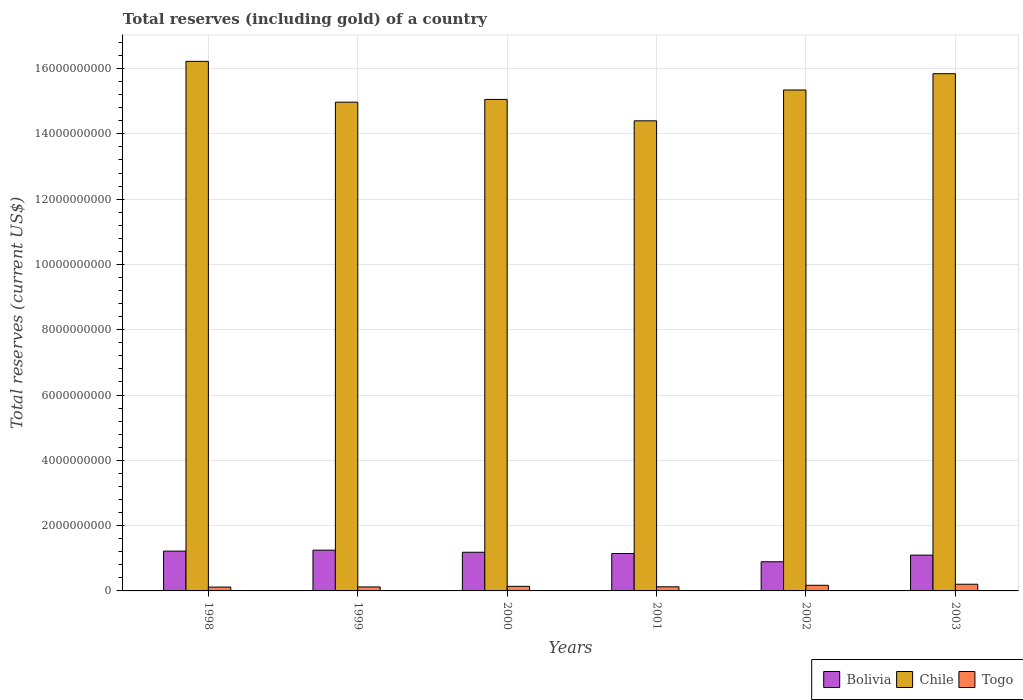How many different coloured bars are there?
Your answer should be very brief. 3. How many groups of bars are there?
Keep it short and to the point. 6. Are the number of bars per tick equal to the number of legend labels?
Provide a succinct answer. Yes. What is the label of the 4th group of bars from the left?
Provide a succinct answer. 2001. What is the total reserves (including gold) in Togo in 2003?
Keep it short and to the point. 2.05e+08. Across all years, what is the maximum total reserves (including gold) in Togo?
Give a very brief answer. 2.05e+08. Across all years, what is the minimum total reserves (including gold) in Bolivia?
Provide a short and direct response. 8.93e+08. In which year was the total reserves (including gold) in Bolivia maximum?
Offer a terse response. 1999. What is the total total reserves (including gold) in Bolivia in the graph?
Provide a succinct answer. 6.79e+09. What is the difference between the total reserves (including gold) in Togo in 1999 and that in 2003?
Offer a very short reply. -8.28e+07. What is the difference between the total reserves (including gold) in Togo in 2000 and the total reserves (including gold) in Chile in 2001?
Ensure brevity in your answer.  -1.43e+1. What is the average total reserves (including gold) in Chile per year?
Offer a terse response. 1.53e+1. In the year 2003, what is the difference between the total reserves (including gold) in Togo and total reserves (including gold) in Chile?
Provide a succinct answer. -1.56e+1. What is the ratio of the total reserves (including gold) in Chile in 1999 to that in 2000?
Keep it short and to the point. 0.99. What is the difference between the highest and the second highest total reserves (including gold) in Bolivia?
Keep it short and to the point. 2.97e+07. What is the difference between the highest and the lowest total reserves (including gold) in Bolivia?
Offer a terse response. 3.56e+08. In how many years, is the total reserves (including gold) in Chile greater than the average total reserves (including gold) in Chile taken over all years?
Your response must be concise. 3. Is the sum of the total reserves (including gold) in Bolivia in 1998 and 2000 greater than the maximum total reserves (including gold) in Togo across all years?
Give a very brief answer. Yes. What does the 3rd bar from the left in 2001 represents?
Your answer should be compact. Togo. What does the 1st bar from the right in 2000 represents?
Your answer should be compact. Togo. How many bars are there?
Give a very brief answer. 18. Does the graph contain any zero values?
Offer a very short reply. No. Does the graph contain grids?
Provide a short and direct response. Yes. Where does the legend appear in the graph?
Offer a very short reply. Bottom right. How many legend labels are there?
Offer a very short reply. 3. How are the legend labels stacked?
Your response must be concise. Horizontal. What is the title of the graph?
Provide a short and direct response. Total reserves (including gold) of a country. Does "Upper middle income" appear as one of the legend labels in the graph?
Offer a terse response. No. What is the label or title of the Y-axis?
Give a very brief answer. Total reserves (current US$). What is the Total reserves (current US$) of Bolivia in 1998?
Your answer should be compact. 1.22e+09. What is the Total reserves (current US$) of Chile in 1998?
Provide a succinct answer. 1.62e+1. What is the Total reserves (current US$) in Togo in 1998?
Give a very brief answer. 1.18e+08. What is the Total reserves (current US$) in Bolivia in 1999?
Your answer should be very brief. 1.25e+09. What is the Total reserves (current US$) of Chile in 1999?
Make the answer very short. 1.50e+1. What is the Total reserves (current US$) in Togo in 1999?
Make the answer very short. 1.22e+08. What is the Total reserves (current US$) of Bolivia in 2000?
Offer a very short reply. 1.18e+09. What is the Total reserves (current US$) of Chile in 2000?
Make the answer very short. 1.51e+1. What is the Total reserves (current US$) of Togo in 2000?
Give a very brief answer. 1.41e+08. What is the Total reserves (current US$) in Bolivia in 2001?
Provide a succinct answer. 1.15e+09. What is the Total reserves (current US$) in Chile in 2001?
Provide a succinct answer. 1.44e+1. What is the Total reserves (current US$) in Togo in 2001?
Your answer should be very brief. 1.26e+08. What is the Total reserves (current US$) in Bolivia in 2002?
Offer a very short reply. 8.93e+08. What is the Total reserves (current US$) in Chile in 2002?
Your answer should be compact. 1.53e+1. What is the Total reserves (current US$) of Togo in 2002?
Ensure brevity in your answer.  1.72e+08. What is the Total reserves (current US$) of Bolivia in 2003?
Offer a terse response. 1.10e+09. What is the Total reserves (current US$) in Chile in 2003?
Offer a terse response. 1.58e+1. What is the Total reserves (current US$) of Togo in 2003?
Offer a very short reply. 2.05e+08. Across all years, what is the maximum Total reserves (current US$) in Bolivia?
Your response must be concise. 1.25e+09. Across all years, what is the maximum Total reserves (current US$) in Chile?
Keep it short and to the point. 1.62e+1. Across all years, what is the maximum Total reserves (current US$) in Togo?
Offer a terse response. 2.05e+08. Across all years, what is the minimum Total reserves (current US$) in Bolivia?
Provide a short and direct response. 8.93e+08. Across all years, what is the minimum Total reserves (current US$) of Chile?
Keep it short and to the point. 1.44e+1. Across all years, what is the minimum Total reserves (current US$) of Togo?
Provide a short and direct response. 1.18e+08. What is the total Total reserves (current US$) in Bolivia in the graph?
Offer a very short reply. 6.79e+09. What is the total Total reserves (current US$) in Chile in the graph?
Your answer should be compact. 9.18e+1. What is the total Total reserves (current US$) in Togo in the graph?
Your answer should be compact. 8.84e+08. What is the difference between the Total reserves (current US$) of Bolivia in 1998 and that in 1999?
Keep it short and to the point. -2.97e+07. What is the difference between the Total reserves (current US$) in Chile in 1998 and that in 1999?
Provide a short and direct response. 1.25e+09. What is the difference between the Total reserves (current US$) of Togo in 1998 and that in 1999?
Give a very brief answer. -4.31e+06. What is the difference between the Total reserves (current US$) in Bolivia in 1998 and that in 2000?
Offer a terse response. 3.48e+07. What is the difference between the Total reserves (current US$) of Chile in 1998 and that in 2000?
Offer a terse response. 1.17e+09. What is the difference between the Total reserves (current US$) of Togo in 1998 and that in 2000?
Provide a short and direct response. -2.31e+07. What is the difference between the Total reserves (current US$) of Bolivia in 1998 and that in 2001?
Offer a terse response. 7.28e+07. What is the difference between the Total reserves (current US$) in Chile in 1998 and that in 2001?
Ensure brevity in your answer.  1.82e+09. What is the difference between the Total reserves (current US$) of Togo in 1998 and that in 2001?
Your answer should be very brief. -8.42e+06. What is the difference between the Total reserves (current US$) of Bolivia in 1998 and that in 2002?
Your answer should be very brief. 3.26e+08. What is the difference between the Total reserves (current US$) of Chile in 1998 and that in 2002?
Keep it short and to the point. 8.77e+08. What is the difference between the Total reserves (current US$) in Togo in 1998 and that in 2002?
Provide a short and direct response. -5.47e+07. What is the difference between the Total reserves (current US$) of Bolivia in 1998 and that in 2003?
Make the answer very short. 1.22e+08. What is the difference between the Total reserves (current US$) of Chile in 1998 and that in 2003?
Keep it short and to the point. 3.78e+08. What is the difference between the Total reserves (current US$) of Togo in 1998 and that in 2003?
Give a very brief answer. -8.71e+07. What is the difference between the Total reserves (current US$) of Bolivia in 1999 and that in 2000?
Make the answer very short. 6.45e+07. What is the difference between the Total reserves (current US$) of Chile in 1999 and that in 2000?
Offer a very short reply. -8.45e+07. What is the difference between the Total reserves (current US$) in Togo in 1999 and that in 2000?
Your answer should be compact. -1.88e+07. What is the difference between the Total reserves (current US$) in Bolivia in 1999 and that in 2001?
Ensure brevity in your answer.  1.03e+08. What is the difference between the Total reserves (current US$) in Chile in 1999 and that in 2001?
Ensure brevity in your answer.  5.71e+08. What is the difference between the Total reserves (current US$) of Togo in 1999 and that in 2001?
Offer a very short reply. -4.11e+06. What is the difference between the Total reserves (current US$) in Bolivia in 1999 and that in 2002?
Give a very brief answer. 3.56e+08. What is the difference between the Total reserves (current US$) of Chile in 1999 and that in 2002?
Your answer should be compact. -3.73e+08. What is the difference between the Total reserves (current US$) in Togo in 1999 and that in 2002?
Provide a short and direct response. -5.04e+07. What is the difference between the Total reserves (current US$) in Bolivia in 1999 and that in 2003?
Give a very brief answer. 1.52e+08. What is the difference between the Total reserves (current US$) in Chile in 1999 and that in 2003?
Offer a terse response. -8.72e+08. What is the difference between the Total reserves (current US$) in Togo in 1999 and that in 2003?
Ensure brevity in your answer.  -8.28e+07. What is the difference between the Total reserves (current US$) of Bolivia in 2000 and that in 2001?
Ensure brevity in your answer.  3.81e+07. What is the difference between the Total reserves (current US$) in Chile in 2000 and that in 2001?
Keep it short and to the point. 6.56e+08. What is the difference between the Total reserves (current US$) of Togo in 2000 and that in 2001?
Offer a very short reply. 1.47e+07. What is the difference between the Total reserves (current US$) in Bolivia in 2000 and that in 2002?
Keep it short and to the point. 2.91e+08. What is the difference between the Total reserves (current US$) in Chile in 2000 and that in 2002?
Ensure brevity in your answer.  -2.89e+08. What is the difference between the Total reserves (current US$) in Togo in 2000 and that in 2002?
Offer a very short reply. -3.16e+07. What is the difference between the Total reserves (current US$) of Bolivia in 2000 and that in 2003?
Your answer should be very brief. 8.72e+07. What is the difference between the Total reserves (current US$) of Chile in 2000 and that in 2003?
Your response must be concise. -7.88e+08. What is the difference between the Total reserves (current US$) in Togo in 2000 and that in 2003?
Your response must be concise. -6.40e+07. What is the difference between the Total reserves (current US$) of Bolivia in 2001 and that in 2002?
Provide a short and direct response. 2.53e+08. What is the difference between the Total reserves (current US$) of Chile in 2001 and that in 2002?
Provide a succinct answer. -9.44e+08. What is the difference between the Total reserves (current US$) of Togo in 2001 and that in 2002?
Offer a terse response. -4.63e+07. What is the difference between the Total reserves (current US$) in Bolivia in 2001 and that in 2003?
Your response must be concise. 4.91e+07. What is the difference between the Total reserves (current US$) of Chile in 2001 and that in 2003?
Your answer should be compact. -1.44e+09. What is the difference between the Total reserves (current US$) in Togo in 2001 and that in 2003?
Your answer should be very brief. -7.87e+07. What is the difference between the Total reserves (current US$) in Bolivia in 2002 and that in 2003?
Provide a succinct answer. -2.04e+08. What is the difference between the Total reserves (current US$) in Chile in 2002 and that in 2003?
Make the answer very short. -4.99e+08. What is the difference between the Total reserves (current US$) of Togo in 2002 and that in 2003?
Keep it short and to the point. -3.25e+07. What is the difference between the Total reserves (current US$) of Bolivia in 1998 and the Total reserves (current US$) of Chile in 1999?
Your answer should be compact. -1.38e+1. What is the difference between the Total reserves (current US$) of Bolivia in 1998 and the Total reserves (current US$) of Togo in 1999?
Keep it short and to the point. 1.10e+09. What is the difference between the Total reserves (current US$) of Chile in 1998 and the Total reserves (current US$) of Togo in 1999?
Offer a terse response. 1.61e+1. What is the difference between the Total reserves (current US$) in Bolivia in 1998 and the Total reserves (current US$) in Chile in 2000?
Your answer should be very brief. -1.38e+1. What is the difference between the Total reserves (current US$) of Bolivia in 1998 and the Total reserves (current US$) of Togo in 2000?
Your response must be concise. 1.08e+09. What is the difference between the Total reserves (current US$) of Chile in 1998 and the Total reserves (current US$) of Togo in 2000?
Offer a very short reply. 1.61e+1. What is the difference between the Total reserves (current US$) in Bolivia in 1998 and the Total reserves (current US$) in Chile in 2001?
Make the answer very short. -1.32e+1. What is the difference between the Total reserves (current US$) of Bolivia in 1998 and the Total reserves (current US$) of Togo in 2001?
Make the answer very short. 1.09e+09. What is the difference between the Total reserves (current US$) in Chile in 1998 and the Total reserves (current US$) in Togo in 2001?
Ensure brevity in your answer.  1.61e+1. What is the difference between the Total reserves (current US$) of Bolivia in 1998 and the Total reserves (current US$) of Chile in 2002?
Give a very brief answer. -1.41e+1. What is the difference between the Total reserves (current US$) of Bolivia in 1998 and the Total reserves (current US$) of Togo in 2002?
Ensure brevity in your answer.  1.05e+09. What is the difference between the Total reserves (current US$) in Chile in 1998 and the Total reserves (current US$) in Togo in 2002?
Provide a short and direct response. 1.60e+1. What is the difference between the Total reserves (current US$) of Bolivia in 1998 and the Total reserves (current US$) of Chile in 2003?
Your response must be concise. -1.46e+1. What is the difference between the Total reserves (current US$) in Bolivia in 1998 and the Total reserves (current US$) in Togo in 2003?
Offer a very short reply. 1.01e+09. What is the difference between the Total reserves (current US$) in Chile in 1998 and the Total reserves (current US$) in Togo in 2003?
Offer a terse response. 1.60e+1. What is the difference between the Total reserves (current US$) in Bolivia in 1999 and the Total reserves (current US$) in Chile in 2000?
Give a very brief answer. -1.38e+1. What is the difference between the Total reserves (current US$) in Bolivia in 1999 and the Total reserves (current US$) in Togo in 2000?
Offer a terse response. 1.11e+09. What is the difference between the Total reserves (current US$) in Chile in 1999 and the Total reserves (current US$) in Togo in 2000?
Provide a succinct answer. 1.48e+1. What is the difference between the Total reserves (current US$) in Bolivia in 1999 and the Total reserves (current US$) in Chile in 2001?
Your answer should be compact. -1.32e+1. What is the difference between the Total reserves (current US$) of Bolivia in 1999 and the Total reserves (current US$) of Togo in 2001?
Offer a very short reply. 1.12e+09. What is the difference between the Total reserves (current US$) in Chile in 1999 and the Total reserves (current US$) in Togo in 2001?
Keep it short and to the point. 1.48e+1. What is the difference between the Total reserves (current US$) in Bolivia in 1999 and the Total reserves (current US$) in Chile in 2002?
Your answer should be compact. -1.41e+1. What is the difference between the Total reserves (current US$) in Bolivia in 1999 and the Total reserves (current US$) in Togo in 2002?
Offer a terse response. 1.08e+09. What is the difference between the Total reserves (current US$) of Chile in 1999 and the Total reserves (current US$) of Togo in 2002?
Keep it short and to the point. 1.48e+1. What is the difference between the Total reserves (current US$) of Bolivia in 1999 and the Total reserves (current US$) of Chile in 2003?
Your answer should be very brief. -1.46e+1. What is the difference between the Total reserves (current US$) of Bolivia in 1999 and the Total reserves (current US$) of Togo in 2003?
Provide a succinct answer. 1.04e+09. What is the difference between the Total reserves (current US$) of Chile in 1999 and the Total reserves (current US$) of Togo in 2003?
Your answer should be compact. 1.48e+1. What is the difference between the Total reserves (current US$) of Bolivia in 2000 and the Total reserves (current US$) of Chile in 2001?
Ensure brevity in your answer.  -1.32e+1. What is the difference between the Total reserves (current US$) of Bolivia in 2000 and the Total reserves (current US$) of Togo in 2001?
Provide a succinct answer. 1.06e+09. What is the difference between the Total reserves (current US$) in Chile in 2000 and the Total reserves (current US$) in Togo in 2001?
Offer a very short reply. 1.49e+1. What is the difference between the Total reserves (current US$) of Bolivia in 2000 and the Total reserves (current US$) of Chile in 2002?
Ensure brevity in your answer.  -1.42e+1. What is the difference between the Total reserves (current US$) in Bolivia in 2000 and the Total reserves (current US$) in Togo in 2002?
Ensure brevity in your answer.  1.01e+09. What is the difference between the Total reserves (current US$) in Chile in 2000 and the Total reserves (current US$) in Togo in 2002?
Keep it short and to the point. 1.49e+1. What is the difference between the Total reserves (current US$) of Bolivia in 2000 and the Total reserves (current US$) of Chile in 2003?
Provide a short and direct response. -1.47e+1. What is the difference between the Total reserves (current US$) in Bolivia in 2000 and the Total reserves (current US$) in Togo in 2003?
Provide a succinct answer. 9.79e+08. What is the difference between the Total reserves (current US$) of Chile in 2000 and the Total reserves (current US$) of Togo in 2003?
Your response must be concise. 1.49e+1. What is the difference between the Total reserves (current US$) of Bolivia in 2001 and the Total reserves (current US$) of Chile in 2002?
Offer a terse response. -1.42e+1. What is the difference between the Total reserves (current US$) in Bolivia in 2001 and the Total reserves (current US$) in Togo in 2002?
Your answer should be compact. 9.74e+08. What is the difference between the Total reserves (current US$) in Chile in 2001 and the Total reserves (current US$) in Togo in 2002?
Your answer should be compact. 1.42e+1. What is the difference between the Total reserves (current US$) in Bolivia in 2001 and the Total reserves (current US$) in Chile in 2003?
Your answer should be compact. -1.47e+1. What is the difference between the Total reserves (current US$) in Bolivia in 2001 and the Total reserves (current US$) in Togo in 2003?
Your response must be concise. 9.41e+08. What is the difference between the Total reserves (current US$) in Chile in 2001 and the Total reserves (current US$) in Togo in 2003?
Give a very brief answer. 1.42e+1. What is the difference between the Total reserves (current US$) in Bolivia in 2002 and the Total reserves (current US$) in Chile in 2003?
Your answer should be compact. -1.50e+1. What is the difference between the Total reserves (current US$) of Bolivia in 2002 and the Total reserves (current US$) of Togo in 2003?
Provide a succinct answer. 6.88e+08. What is the difference between the Total reserves (current US$) in Chile in 2002 and the Total reserves (current US$) in Togo in 2003?
Your answer should be compact. 1.51e+1. What is the average Total reserves (current US$) of Bolivia per year?
Provide a succinct answer. 1.13e+09. What is the average Total reserves (current US$) in Chile per year?
Provide a succinct answer. 1.53e+1. What is the average Total reserves (current US$) in Togo per year?
Your answer should be compact. 1.47e+08. In the year 1998, what is the difference between the Total reserves (current US$) in Bolivia and Total reserves (current US$) in Chile?
Your response must be concise. -1.50e+1. In the year 1998, what is the difference between the Total reserves (current US$) in Bolivia and Total reserves (current US$) in Togo?
Provide a succinct answer. 1.10e+09. In the year 1998, what is the difference between the Total reserves (current US$) of Chile and Total reserves (current US$) of Togo?
Ensure brevity in your answer.  1.61e+1. In the year 1999, what is the difference between the Total reserves (current US$) of Bolivia and Total reserves (current US$) of Chile?
Your answer should be compact. -1.37e+1. In the year 1999, what is the difference between the Total reserves (current US$) of Bolivia and Total reserves (current US$) of Togo?
Provide a short and direct response. 1.13e+09. In the year 1999, what is the difference between the Total reserves (current US$) of Chile and Total reserves (current US$) of Togo?
Give a very brief answer. 1.48e+1. In the year 2000, what is the difference between the Total reserves (current US$) of Bolivia and Total reserves (current US$) of Chile?
Your answer should be compact. -1.39e+1. In the year 2000, what is the difference between the Total reserves (current US$) in Bolivia and Total reserves (current US$) in Togo?
Offer a terse response. 1.04e+09. In the year 2000, what is the difference between the Total reserves (current US$) in Chile and Total reserves (current US$) in Togo?
Your answer should be compact. 1.49e+1. In the year 2001, what is the difference between the Total reserves (current US$) in Bolivia and Total reserves (current US$) in Chile?
Give a very brief answer. -1.33e+1. In the year 2001, what is the difference between the Total reserves (current US$) of Bolivia and Total reserves (current US$) of Togo?
Provide a short and direct response. 1.02e+09. In the year 2001, what is the difference between the Total reserves (current US$) in Chile and Total reserves (current US$) in Togo?
Offer a very short reply. 1.43e+1. In the year 2002, what is the difference between the Total reserves (current US$) in Bolivia and Total reserves (current US$) in Chile?
Your answer should be very brief. -1.45e+1. In the year 2002, what is the difference between the Total reserves (current US$) of Bolivia and Total reserves (current US$) of Togo?
Your response must be concise. 7.20e+08. In the year 2002, what is the difference between the Total reserves (current US$) of Chile and Total reserves (current US$) of Togo?
Your response must be concise. 1.52e+1. In the year 2003, what is the difference between the Total reserves (current US$) in Bolivia and Total reserves (current US$) in Chile?
Provide a short and direct response. -1.47e+1. In the year 2003, what is the difference between the Total reserves (current US$) of Bolivia and Total reserves (current US$) of Togo?
Your answer should be very brief. 8.92e+08. In the year 2003, what is the difference between the Total reserves (current US$) in Chile and Total reserves (current US$) in Togo?
Offer a terse response. 1.56e+1. What is the ratio of the Total reserves (current US$) of Bolivia in 1998 to that in 1999?
Ensure brevity in your answer.  0.98. What is the ratio of the Total reserves (current US$) in Chile in 1998 to that in 1999?
Ensure brevity in your answer.  1.08. What is the ratio of the Total reserves (current US$) in Togo in 1998 to that in 1999?
Your response must be concise. 0.96. What is the ratio of the Total reserves (current US$) of Bolivia in 1998 to that in 2000?
Your answer should be very brief. 1.03. What is the ratio of the Total reserves (current US$) in Chile in 1998 to that in 2000?
Your answer should be very brief. 1.08. What is the ratio of the Total reserves (current US$) in Togo in 1998 to that in 2000?
Ensure brevity in your answer.  0.84. What is the ratio of the Total reserves (current US$) in Bolivia in 1998 to that in 2001?
Offer a terse response. 1.06. What is the ratio of the Total reserves (current US$) of Chile in 1998 to that in 2001?
Provide a short and direct response. 1.13. What is the ratio of the Total reserves (current US$) in Bolivia in 1998 to that in 2002?
Provide a short and direct response. 1.37. What is the ratio of the Total reserves (current US$) of Chile in 1998 to that in 2002?
Your response must be concise. 1.06. What is the ratio of the Total reserves (current US$) in Togo in 1998 to that in 2002?
Your response must be concise. 0.68. What is the ratio of the Total reserves (current US$) in Bolivia in 1998 to that in 2003?
Ensure brevity in your answer.  1.11. What is the ratio of the Total reserves (current US$) of Chile in 1998 to that in 2003?
Provide a succinct answer. 1.02. What is the ratio of the Total reserves (current US$) in Togo in 1998 to that in 2003?
Your answer should be compact. 0.57. What is the ratio of the Total reserves (current US$) of Bolivia in 1999 to that in 2000?
Your answer should be compact. 1.05. What is the ratio of the Total reserves (current US$) in Togo in 1999 to that in 2000?
Offer a terse response. 0.87. What is the ratio of the Total reserves (current US$) in Bolivia in 1999 to that in 2001?
Your answer should be compact. 1.09. What is the ratio of the Total reserves (current US$) of Chile in 1999 to that in 2001?
Give a very brief answer. 1.04. What is the ratio of the Total reserves (current US$) in Togo in 1999 to that in 2001?
Give a very brief answer. 0.97. What is the ratio of the Total reserves (current US$) in Bolivia in 1999 to that in 2002?
Offer a terse response. 1.4. What is the ratio of the Total reserves (current US$) in Chile in 1999 to that in 2002?
Offer a very short reply. 0.98. What is the ratio of the Total reserves (current US$) in Togo in 1999 to that in 2002?
Your response must be concise. 0.71. What is the ratio of the Total reserves (current US$) in Bolivia in 1999 to that in 2003?
Make the answer very short. 1.14. What is the ratio of the Total reserves (current US$) in Chile in 1999 to that in 2003?
Offer a terse response. 0.94. What is the ratio of the Total reserves (current US$) of Togo in 1999 to that in 2003?
Keep it short and to the point. 0.6. What is the ratio of the Total reserves (current US$) in Bolivia in 2000 to that in 2001?
Give a very brief answer. 1.03. What is the ratio of the Total reserves (current US$) in Chile in 2000 to that in 2001?
Ensure brevity in your answer.  1.05. What is the ratio of the Total reserves (current US$) of Togo in 2000 to that in 2001?
Your answer should be very brief. 1.12. What is the ratio of the Total reserves (current US$) in Bolivia in 2000 to that in 2002?
Your response must be concise. 1.33. What is the ratio of the Total reserves (current US$) of Chile in 2000 to that in 2002?
Ensure brevity in your answer.  0.98. What is the ratio of the Total reserves (current US$) in Togo in 2000 to that in 2002?
Give a very brief answer. 0.82. What is the ratio of the Total reserves (current US$) in Bolivia in 2000 to that in 2003?
Keep it short and to the point. 1.08. What is the ratio of the Total reserves (current US$) in Chile in 2000 to that in 2003?
Your response must be concise. 0.95. What is the ratio of the Total reserves (current US$) of Togo in 2000 to that in 2003?
Offer a very short reply. 0.69. What is the ratio of the Total reserves (current US$) in Bolivia in 2001 to that in 2002?
Offer a terse response. 1.28. What is the ratio of the Total reserves (current US$) of Chile in 2001 to that in 2002?
Provide a short and direct response. 0.94. What is the ratio of the Total reserves (current US$) of Togo in 2001 to that in 2002?
Your answer should be very brief. 0.73. What is the ratio of the Total reserves (current US$) in Bolivia in 2001 to that in 2003?
Give a very brief answer. 1.04. What is the ratio of the Total reserves (current US$) of Chile in 2001 to that in 2003?
Ensure brevity in your answer.  0.91. What is the ratio of the Total reserves (current US$) in Togo in 2001 to that in 2003?
Offer a very short reply. 0.62. What is the ratio of the Total reserves (current US$) in Bolivia in 2002 to that in 2003?
Make the answer very short. 0.81. What is the ratio of the Total reserves (current US$) in Chile in 2002 to that in 2003?
Offer a very short reply. 0.97. What is the ratio of the Total reserves (current US$) in Togo in 2002 to that in 2003?
Keep it short and to the point. 0.84. What is the difference between the highest and the second highest Total reserves (current US$) in Bolivia?
Provide a short and direct response. 2.97e+07. What is the difference between the highest and the second highest Total reserves (current US$) in Chile?
Your answer should be compact. 3.78e+08. What is the difference between the highest and the second highest Total reserves (current US$) in Togo?
Make the answer very short. 3.25e+07. What is the difference between the highest and the lowest Total reserves (current US$) of Bolivia?
Your answer should be very brief. 3.56e+08. What is the difference between the highest and the lowest Total reserves (current US$) of Chile?
Give a very brief answer. 1.82e+09. What is the difference between the highest and the lowest Total reserves (current US$) of Togo?
Keep it short and to the point. 8.71e+07. 